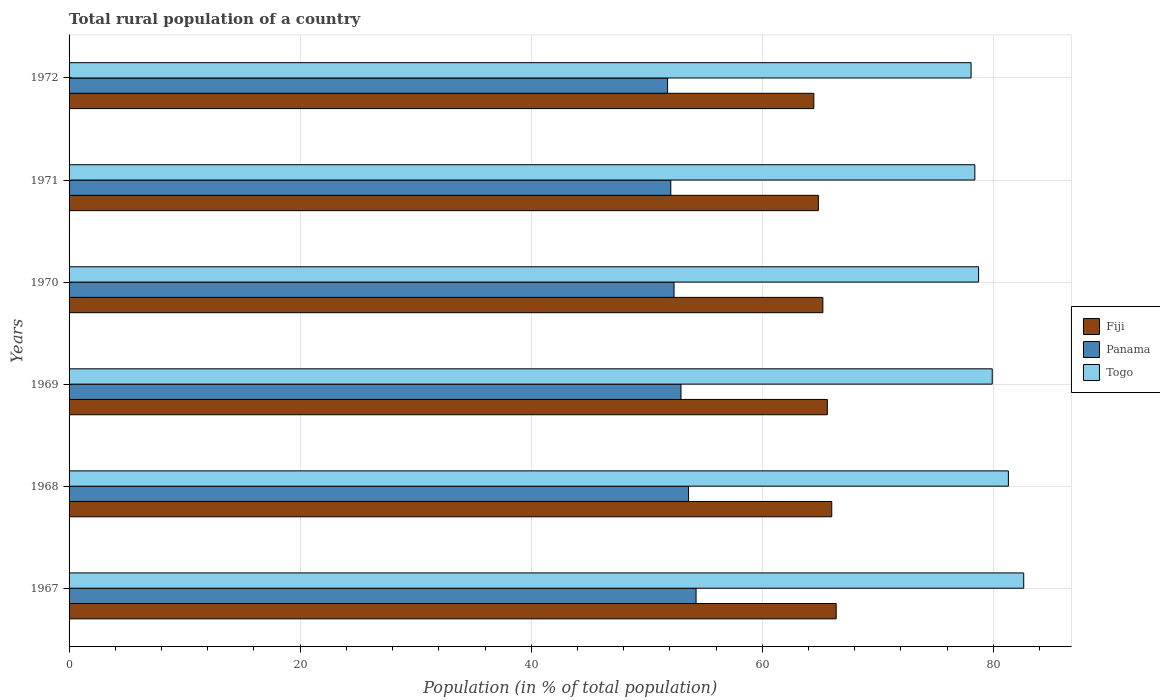How many different coloured bars are there?
Ensure brevity in your answer.  3. How many bars are there on the 3rd tick from the top?
Provide a short and direct response. 3. What is the label of the 6th group of bars from the top?
Make the answer very short. 1967. What is the rural population in Fiji in 1971?
Offer a very short reply. 64.85. Across all years, what is the maximum rural population in Panama?
Your answer should be very brief. 54.27. Across all years, what is the minimum rural population in Panama?
Ensure brevity in your answer.  51.8. In which year was the rural population in Togo maximum?
Give a very brief answer. 1967. What is the total rural population in Fiji in the graph?
Offer a terse response. 392.59. What is the difference between the rural population in Fiji in 1968 and that in 1971?
Offer a very short reply. 1.16. What is the difference between the rural population in Panama in 1971 and the rural population in Fiji in 1969?
Ensure brevity in your answer.  -13.55. What is the average rural population in Togo per year?
Keep it short and to the point. 79.84. In the year 1971, what is the difference between the rural population in Fiji and rural population in Panama?
Your answer should be compact. 12.77. In how many years, is the rural population in Panama greater than 24 %?
Keep it short and to the point. 6. What is the ratio of the rural population in Panama in 1970 to that in 1971?
Offer a terse response. 1.01. Is the rural population in Togo in 1968 less than that in 1971?
Offer a terse response. No. What is the difference between the highest and the second highest rural population in Togo?
Provide a succinct answer. 1.33. What is the difference between the highest and the lowest rural population in Fiji?
Offer a very short reply. 1.93. What does the 2nd bar from the top in 1970 represents?
Your answer should be compact. Panama. What does the 1st bar from the bottom in 1967 represents?
Offer a very short reply. Fiji. Is it the case that in every year, the sum of the rural population in Panama and rural population in Fiji is greater than the rural population in Togo?
Give a very brief answer. Yes. How many bars are there?
Make the answer very short. 18. What is the difference between two consecutive major ticks on the X-axis?
Keep it short and to the point. 20. Are the values on the major ticks of X-axis written in scientific E-notation?
Provide a succinct answer. No. Where does the legend appear in the graph?
Provide a succinct answer. Center right. How many legend labels are there?
Offer a terse response. 3. What is the title of the graph?
Offer a terse response. Total rural population of a country. Does "Canada" appear as one of the legend labels in the graph?
Keep it short and to the point. No. What is the label or title of the X-axis?
Offer a very short reply. Population (in % of total population). What is the label or title of the Y-axis?
Keep it short and to the point. Years. What is the Population (in % of total population) of Fiji in 1967?
Offer a very short reply. 66.4. What is the Population (in % of total population) of Panama in 1967?
Your response must be concise. 54.27. What is the Population (in % of total population) in Togo in 1967?
Offer a very short reply. 82.63. What is the Population (in % of total population) of Fiji in 1968?
Keep it short and to the point. 66.01. What is the Population (in % of total population) of Panama in 1968?
Ensure brevity in your answer.  53.62. What is the Population (in % of total population) of Togo in 1968?
Offer a terse response. 81.3. What is the Population (in % of total population) in Fiji in 1969?
Offer a terse response. 65.63. What is the Population (in % of total population) in Panama in 1969?
Give a very brief answer. 52.96. What is the Population (in % of total population) of Togo in 1969?
Give a very brief answer. 79.9. What is the Population (in % of total population) in Fiji in 1970?
Give a very brief answer. 65.24. What is the Population (in % of total population) of Panama in 1970?
Give a very brief answer. 52.36. What is the Population (in % of total population) in Togo in 1970?
Keep it short and to the point. 78.72. What is the Population (in % of total population) in Fiji in 1971?
Provide a succinct answer. 64.85. What is the Population (in % of total population) of Panama in 1971?
Make the answer very short. 52.08. What is the Population (in % of total population) of Togo in 1971?
Provide a short and direct response. 78.4. What is the Population (in % of total population) in Fiji in 1972?
Ensure brevity in your answer.  64.46. What is the Population (in % of total population) of Panama in 1972?
Ensure brevity in your answer.  51.8. What is the Population (in % of total population) of Togo in 1972?
Your response must be concise. 78.07. Across all years, what is the maximum Population (in % of total population) of Fiji?
Give a very brief answer. 66.4. Across all years, what is the maximum Population (in % of total population) of Panama?
Offer a very short reply. 54.27. Across all years, what is the maximum Population (in % of total population) of Togo?
Your response must be concise. 82.63. Across all years, what is the minimum Population (in % of total population) of Fiji?
Offer a very short reply. 64.46. Across all years, what is the minimum Population (in % of total population) in Panama?
Make the answer very short. 51.8. Across all years, what is the minimum Population (in % of total population) in Togo?
Your response must be concise. 78.07. What is the total Population (in % of total population) in Fiji in the graph?
Keep it short and to the point. 392.6. What is the total Population (in % of total population) in Panama in the graph?
Your response must be concise. 317.09. What is the total Population (in % of total population) in Togo in the graph?
Your response must be concise. 479.02. What is the difference between the Population (in % of total population) in Fiji in 1967 and that in 1968?
Give a very brief answer. 0.38. What is the difference between the Population (in % of total population) of Panama in 1967 and that in 1968?
Give a very brief answer. 0.65. What is the difference between the Population (in % of total population) of Togo in 1967 and that in 1968?
Ensure brevity in your answer.  1.33. What is the difference between the Population (in % of total population) in Fiji in 1967 and that in 1969?
Make the answer very short. 0.77. What is the difference between the Population (in % of total population) in Panama in 1967 and that in 1969?
Your response must be concise. 1.31. What is the difference between the Population (in % of total population) in Togo in 1967 and that in 1969?
Ensure brevity in your answer.  2.72. What is the difference between the Population (in % of total population) in Fiji in 1967 and that in 1970?
Your response must be concise. 1.15. What is the difference between the Population (in % of total population) in Panama in 1967 and that in 1970?
Your answer should be compact. 1.91. What is the difference between the Population (in % of total population) of Togo in 1967 and that in 1970?
Make the answer very short. 3.91. What is the difference between the Population (in % of total population) in Fiji in 1967 and that in 1971?
Your answer should be compact. 1.54. What is the difference between the Population (in % of total population) in Panama in 1967 and that in 1971?
Offer a very short reply. 2.19. What is the difference between the Population (in % of total population) of Togo in 1967 and that in 1971?
Provide a succinct answer. 4.23. What is the difference between the Population (in % of total population) in Fiji in 1967 and that in 1972?
Offer a very short reply. 1.93. What is the difference between the Population (in % of total population) of Panama in 1967 and that in 1972?
Ensure brevity in your answer.  2.47. What is the difference between the Population (in % of total population) of Togo in 1967 and that in 1972?
Keep it short and to the point. 4.55. What is the difference between the Population (in % of total population) of Fiji in 1968 and that in 1969?
Offer a very short reply. 0.38. What is the difference between the Population (in % of total population) in Panama in 1968 and that in 1969?
Offer a very short reply. 0.65. What is the difference between the Population (in % of total population) of Togo in 1968 and that in 1969?
Provide a short and direct response. 1.4. What is the difference between the Population (in % of total population) of Fiji in 1968 and that in 1970?
Offer a terse response. 0.77. What is the difference between the Population (in % of total population) of Panama in 1968 and that in 1970?
Provide a succinct answer. 1.25. What is the difference between the Population (in % of total population) in Togo in 1968 and that in 1970?
Your answer should be very brief. 2.58. What is the difference between the Population (in % of total population) of Fiji in 1968 and that in 1971?
Offer a very short reply. 1.16. What is the difference between the Population (in % of total population) of Panama in 1968 and that in 1971?
Offer a terse response. 1.53. What is the difference between the Population (in % of total population) in Togo in 1968 and that in 1971?
Provide a short and direct response. 2.9. What is the difference between the Population (in % of total population) in Fiji in 1968 and that in 1972?
Provide a succinct answer. 1.55. What is the difference between the Population (in % of total population) of Panama in 1968 and that in 1972?
Your answer should be compact. 1.81. What is the difference between the Population (in % of total population) in Togo in 1968 and that in 1972?
Your answer should be very brief. 3.23. What is the difference between the Population (in % of total population) of Fiji in 1969 and that in 1970?
Provide a succinct answer. 0.39. What is the difference between the Population (in % of total population) of Panama in 1969 and that in 1970?
Provide a short and direct response. 0.6. What is the difference between the Population (in % of total population) of Togo in 1969 and that in 1970?
Your answer should be very brief. 1.18. What is the difference between the Population (in % of total population) of Fiji in 1969 and that in 1971?
Your answer should be very brief. 0.78. What is the difference between the Population (in % of total population) of Panama in 1969 and that in 1971?
Give a very brief answer. 0.88. What is the difference between the Population (in % of total population) in Togo in 1969 and that in 1971?
Make the answer very short. 1.5. What is the difference between the Population (in % of total population) of Fiji in 1969 and that in 1972?
Provide a succinct answer. 1.17. What is the difference between the Population (in % of total population) of Panama in 1969 and that in 1972?
Give a very brief answer. 1.16. What is the difference between the Population (in % of total population) in Togo in 1969 and that in 1972?
Give a very brief answer. 1.83. What is the difference between the Population (in % of total population) of Fiji in 1970 and that in 1971?
Ensure brevity in your answer.  0.39. What is the difference between the Population (in % of total population) in Panama in 1970 and that in 1971?
Your answer should be compact. 0.28. What is the difference between the Population (in % of total population) of Togo in 1970 and that in 1971?
Give a very brief answer. 0.32. What is the difference between the Population (in % of total population) of Fiji in 1970 and that in 1972?
Keep it short and to the point. 0.78. What is the difference between the Population (in % of total population) of Panama in 1970 and that in 1972?
Offer a terse response. 0.56. What is the difference between the Population (in % of total population) of Togo in 1970 and that in 1972?
Make the answer very short. 0.65. What is the difference between the Population (in % of total population) in Fiji in 1971 and that in 1972?
Ensure brevity in your answer.  0.39. What is the difference between the Population (in % of total population) in Panama in 1971 and that in 1972?
Provide a succinct answer. 0.28. What is the difference between the Population (in % of total population) of Togo in 1971 and that in 1972?
Your response must be concise. 0.33. What is the difference between the Population (in % of total population) of Fiji in 1967 and the Population (in % of total population) of Panama in 1968?
Ensure brevity in your answer.  12.78. What is the difference between the Population (in % of total population) of Fiji in 1967 and the Population (in % of total population) of Togo in 1968?
Ensure brevity in your answer.  -14.9. What is the difference between the Population (in % of total population) in Panama in 1967 and the Population (in % of total population) in Togo in 1968?
Provide a succinct answer. -27.03. What is the difference between the Population (in % of total population) of Fiji in 1967 and the Population (in % of total population) of Panama in 1969?
Keep it short and to the point. 13.43. What is the difference between the Population (in % of total population) in Fiji in 1967 and the Population (in % of total population) in Togo in 1969?
Make the answer very short. -13.51. What is the difference between the Population (in % of total population) of Panama in 1967 and the Population (in % of total population) of Togo in 1969?
Your answer should be compact. -25.63. What is the difference between the Population (in % of total population) of Fiji in 1967 and the Population (in % of total population) of Panama in 1970?
Provide a succinct answer. 14.04. What is the difference between the Population (in % of total population) in Fiji in 1967 and the Population (in % of total population) in Togo in 1970?
Give a very brief answer. -12.32. What is the difference between the Population (in % of total population) of Panama in 1967 and the Population (in % of total population) of Togo in 1970?
Provide a succinct answer. -24.45. What is the difference between the Population (in % of total population) in Fiji in 1967 and the Population (in % of total population) in Panama in 1971?
Your response must be concise. 14.31. What is the difference between the Population (in % of total population) in Fiji in 1967 and the Population (in % of total population) in Togo in 1971?
Provide a short and direct response. -12. What is the difference between the Population (in % of total population) in Panama in 1967 and the Population (in % of total population) in Togo in 1971?
Give a very brief answer. -24.13. What is the difference between the Population (in % of total population) in Fiji in 1967 and the Population (in % of total population) in Panama in 1972?
Your answer should be very brief. 14.6. What is the difference between the Population (in % of total population) in Fiji in 1967 and the Population (in % of total population) in Togo in 1972?
Offer a terse response. -11.68. What is the difference between the Population (in % of total population) of Panama in 1967 and the Population (in % of total population) of Togo in 1972?
Offer a very short reply. -23.8. What is the difference between the Population (in % of total population) of Fiji in 1968 and the Population (in % of total population) of Panama in 1969?
Make the answer very short. 13.05. What is the difference between the Population (in % of total population) in Fiji in 1968 and the Population (in % of total population) in Togo in 1969?
Give a very brief answer. -13.89. What is the difference between the Population (in % of total population) in Panama in 1968 and the Population (in % of total population) in Togo in 1969?
Your answer should be compact. -26.29. What is the difference between the Population (in % of total population) of Fiji in 1968 and the Population (in % of total population) of Panama in 1970?
Give a very brief answer. 13.65. What is the difference between the Population (in % of total population) in Fiji in 1968 and the Population (in % of total population) in Togo in 1970?
Give a very brief answer. -12.71. What is the difference between the Population (in % of total population) in Panama in 1968 and the Population (in % of total population) in Togo in 1970?
Keep it short and to the point. -25.11. What is the difference between the Population (in % of total population) in Fiji in 1968 and the Population (in % of total population) in Panama in 1971?
Your answer should be very brief. 13.93. What is the difference between the Population (in % of total population) of Fiji in 1968 and the Population (in % of total population) of Togo in 1971?
Your answer should be compact. -12.38. What is the difference between the Population (in % of total population) of Panama in 1968 and the Population (in % of total population) of Togo in 1971?
Provide a succinct answer. -24.78. What is the difference between the Population (in % of total population) of Fiji in 1968 and the Population (in % of total population) of Panama in 1972?
Keep it short and to the point. 14.21. What is the difference between the Population (in % of total population) in Fiji in 1968 and the Population (in % of total population) in Togo in 1972?
Offer a very short reply. -12.06. What is the difference between the Population (in % of total population) in Panama in 1968 and the Population (in % of total population) in Togo in 1972?
Offer a very short reply. -24.46. What is the difference between the Population (in % of total population) of Fiji in 1969 and the Population (in % of total population) of Panama in 1970?
Keep it short and to the point. 13.27. What is the difference between the Population (in % of total population) in Fiji in 1969 and the Population (in % of total population) in Togo in 1970?
Keep it short and to the point. -13.09. What is the difference between the Population (in % of total population) in Panama in 1969 and the Population (in % of total population) in Togo in 1970?
Your response must be concise. -25.76. What is the difference between the Population (in % of total population) of Fiji in 1969 and the Population (in % of total population) of Panama in 1971?
Provide a succinct answer. 13.55. What is the difference between the Population (in % of total population) in Fiji in 1969 and the Population (in % of total population) in Togo in 1971?
Offer a very short reply. -12.77. What is the difference between the Population (in % of total population) in Panama in 1969 and the Population (in % of total population) in Togo in 1971?
Your answer should be compact. -25.44. What is the difference between the Population (in % of total population) of Fiji in 1969 and the Population (in % of total population) of Panama in 1972?
Ensure brevity in your answer.  13.83. What is the difference between the Population (in % of total population) of Fiji in 1969 and the Population (in % of total population) of Togo in 1972?
Your response must be concise. -12.44. What is the difference between the Population (in % of total population) of Panama in 1969 and the Population (in % of total population) of Togo in 1972?
Your answer should be compact. -25.11. What is the difference between the Population (in % of total population) in Fiji in 1970 and the Population (in % of total population) in Panama in 1971?
Offer a terse response. 13.16. What is the difference between the Population (in % of total population) of Fiji in 1970 and the Population (in % of total population) of Togo in 1971?
Your answer should be very brief. -13.16. What is the difference between the Population (in % of total population) of Panama in 1970 and the Population (in % of total population) of Togo in 1971?
Give a very brief answer. -26.04. What is the difference between the Population (in % of total population) of Fiji in 1970 and the Population (in % of total population) of Panama in 1972?
Keep it short and to the point. 13.44. What is the difference between the Population (in % of total population) of Fiji in 1970 and the Population (in % of total population) of Togo in 1972?
Keep it short and to the point. -12.83. What is the difference between the Population (in % of total population) of Panama in 1970 and the Population (in % of total population) of Togo in 1972?
Provide a succinct answer. -25.71. What is the difference between the Population (in % of total population) in Fiji in 1971 and the Population (in % of total population) in Panama in 1972?
Make the answer very short. 13.05. What is the difference between the Population (in % of total population) in Fiji in 1971 and the Population (in % of total population) in Togo in 1972?
Keep it short and to the point. -13.22. What is the difference between the Population (in % of total population) in Panama in 1971 and the Population (in % of total population) in Togo in 1972?
Give a very brief answer. -25.99. What is the average Population (in % of total population) of Fiji per year?
Your answer should be compact. 65.43. What is the average Population (in % of total population) of Panama per year?
Offer a terse response. 52.85. What is the average Population (in % of total population) of Togo per year?
Your answer should be compact. 79.84. In the year 1967, what is the difference between the Population (in % of total population) of Fiji and Population (in % of total population) of Panama?
Your answer should be very brief. 12.13. In the year 1967, what is the difference between the Population (in % of total population) of Fiji and Population (in % of total population) of Togo?
Keep it short and to the point. -16.23. In the year 1967, what is the difference between the Population (in % of total population) of Panama and Population (in % of total population) of Togo?
Provide a short and direct response. -28.36. In the year 1968, what is the difference between the Population (in % of total population) of Fiji and Population (in % of total population) of Panama?
Make the answer very short. 12.4. In the year 1968, what is the difference between the Population (in % of total population) of Fiji and Population (in % of total population) of Togo?
Offer a very short reply. -15.29. In the year 1968, what is the difference between the Population (in % of total population) in Panama and Population (in % of total population) in Togo?
Provide a short and direct response. -27.68. In the year 1969, what is the difference between the Population (in % of total population) in Fiji and Population (in % of total population) in Panama?
Provide a succinct answer. 12.67. In the year 1969, what is the difference between the Population (in % of total population) of Fiji and Population (in % of total population) of Togo?
Provide a short and direct response. -14.27. In the year 1969, what is the difference between the Population (in % of total population) of Panama and Population (in % of total population) of Togo?
Give a very brief answer. -26.94. In the year 1970, what is the difference between the Population (in % of total population) of Fiji and Population (in % of total population) of Panama?
Your answer should be compact. 12.88. In the year 1970, what is the difference between the Population (in % of total population) in Fiji and Population (in % of total population) in Togo?
Offer a very short reply. -13.48. In the year 1970, what is the difference between the Population (in % of total population) in Panama and Population (in % of total population) in Togo?
Your answer should be compact. -26.36. In the year 1971, what is the difference between the Population (in % of total population) in Fiji and Population (in % of total population) in Panama?
Give a very brief answer. 12.77. In the year 1971, what is the difference between the Population (in % of total population) in Fiji and Population (in % of total population) in Togo?
Keep it short and to the point. -13.54. In the year 1971, what is the difference between the Population (in % of total population) of Panama and Population (in % of total population) of Togo?
Provide a succinct answer. -26.32. In the year 1972, what is the difference between the Population (in % of total population) of Fiji and Population (in % of total population) of Panama?
Provide a succinct answer. 12.66. In the year 1972, what is the difference between the Population (in % of total population) of Fiji and Population (in % of total population) of Togo?
Make the answer very short. -13.61. In the year 1972, what is the difference between the Population (in % of total population) in Panama and Population (in % of total population) in Togo?
Ensure brevity in your answer.  -26.27. What is the ratio of the Population (in % of total population) in Fiji in 1967 to that in 1968?
Offer a terse response. 1.01. What is the ratio of the Population (in % of total population) of Panama in 1967 to that in 1968?
Give a very brief answer. 1.01. What is the ratio of the Population (in % of total population) of Togo in 1967 to that in 1968?
Ensure brevity in your answer.  1.02. What is the ratio of the Population (in % of total population) of Fiji in 1967 to that in 1969?
Ensure brevity in your answer.  1.01. What is the ratio of the Population (in % of total population) in Panama in 1967 to that in 1969?
Provide a short and direct response. 1.02. What is the ratio of the Population (in % of total population) in Togo in 1967 to that in 1969?
Provide a short and direct response. 1.03. What is the ratio of the Population (in % of total population) in Fiji in 1967 to that in 1970?
Offer a terse response. 1.02. What is the ratio of the Population (in % of total population) in Panama in 1967 to that in 1970?
Give a very brief answer. 1.04. What is the ratio of the Population (in % of total population) in Togo in 1967 to that in 1970?
Offer a terse response. 1.05. What is the ratio of the Population (in % of total population) in Fiji in 1967 to that in 1971?
Provide a short and direct response. 1.02. What is the ratio of the Population (in % of total population) of Panama in 1967 to that in 1971?
Provide a succinct answer. 1.04. What is the ratio of the Population (in % of total population) of Togo in 1967 to that in 1971?
Your response must be concise. 1.05. What is the ratio of the Population (in % of total population) of Fiji in 1967 to that in 1972?
Ensure brevity in your answer.  1.03. What is the ratio of the Population (in % of total population) in Panama in 1967 to that in 1972?
Make the answer very short. 1.05. What is the ratio of the Population (in % of total population) in Togo in 1967 to that in 1972?
Give a very brief answer. 1.06. What is the ratio of the Population (in % of total population) in Fiji in 1968 to that in 1969?
Ensure brevity in your answer.  1.01. What is the ratio of the Population (in % of total population) in Panama in 1968 to that in 1969?
Offer a very short reply. 1.01. What is the ratio of the Population (in % of total population) of Togo in 1968 to that in 1969?
Provide a short and direct response. 1.02. What is the ratio of the Population (in % of total population) of Fiji in 1968 to that in 1970?
Give a very brief answer. 1.01. What is the ratio of the Population (in % of total population) in Panama in 1968 to that in 1970?
Give a very brief answer. 1.02. What is the ratio of the Population (in % of total population) of Togo in 1968 to that in 1970?
Offer a terse response. 1.03. What is the ratio of the Population (in % of total population) of Fiji in 1968 to that in 1971?
Provide a short and direct response. 1.02. What is the ratio of the Population (in % of total population) of Panama in 1968 to that in 1971?
Offer a terse response. 1.03. What is the ratio of the Population (in % of total population) of Togo in 1968 to that in 1971?
Your answer should be very brief. 1.04. What is the ratio of the Population (in % of total population) of Fiji in 1968 to that in 1972?
Provide a succinct answer. 1.02. What is the ratio of the Population (in % of total population) in Panama in 1968 to that in 1972?
Ensure brevity in your answer.  1.03. What is the ratio of the Population (in % of total population) in Togo in 1968 to that in 1972?
Your answer should be compact. 1.04. What is the ratio of the Population (in % of total population) of Fiji in 1969 to that in 1970?
Ensure brevity in your answer.  1.01. What is the ratio of the Population (in % of total population) in Panama in 1969 to that in 1970?
Your answer should be compact. 1.01. What is the ratio of the Population (in % of total population) of Togo in 1969 to that in 1970?
Provide a succinct answer. 1.01. What is the ratio of the Population (in % of total population) in Panama in 1969 to that in 1971?
Give a very brief answer. 1.02. What is the ratio of the Population (in % of total population) of Togo in 1969 to that in 1971?
Provide a succinct answer. 1.02. What is the ratio of the Population (in % of total population) of Fiji in 1969 to that in 1972?
Provide a short and direct response. 1.02. What is the ratio of the Population (in % of total population) of Panama in 1969 to that in 1972?
Give a very brief answer. 1.02. What is the ratio of the Population (in % of total population) of Togo in 1969 to that in 1972?
Provide a short and direct response. 1.02. What is the ratio of the Population (in % of total population) in Fiji in 1970 to that in 1971?
Ensure brevity in your answer.  1.01. What is the ratio of the Population (in % of total population) in Panama in 1970 to that in 1971?
Your response must be concise. 1.01. What is the ratio of the Population (in % of total population) of Togo in 1970 to that in 1971?
Keep it short and to the point. 1. What is the ratio of the Population (in % of total population) of Fiji in 1970 to that in 1972?
Ensure brevity in your answer.  1.01. What is the ratio of the Population (in % of total population) in Panama in 1970 to that in 1972?
Offer a very short reply. 1.01. What is the ratio of the Population (in % of total population) in Togo in 1970 to that in 1972?
Ensure brevity in your answer.  1.01. What is the ratio of the Population (in % of total population) in Fiji in 1971 to that in 1972?
Ensure brevity in your answer.  1.01. What is the ratio of the Population (in % of total population) of Panama in 1971 to that in 1972?
Your answer should be very brief. 1.01. What is the ratio of the Population (in % of total population) in Togo in 1971 to that in 1972?
Keep it short and to the point. 1. What is the difference between the highest and the second highest Population (in % of total population) in Fiji?
Your answer should be compact. 0.38. What is the difference between the highest and the second highest Population (in % of total population) of Panama?
Keep it short and to the point. 0.65. What is the difference between the highest and the second highest Population (in % of total population) in Togo?
Your response must be concise. 1.33. What is the difference between the highest and the lowest Population (in % of total population) in Fiji?
Give a very brief answer. 1.93. What is the difference between the highest and the lowest Population (in % of total population) in Panama?
Your answer should be compact. 2.47. What is the difference between the highest and the lowest Population (in % of total population) in Togo?
Make the answer very short. 4.55. 